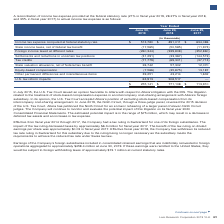According to Lam Research Corporation's financial document, What might the estimated potential impact being in the range of $75 million result in? a decrease in deferred tax assets and an increase in tax expense. The document states: "in the range of $75 million, which may result in a decrease in deferred tax assets and an increase in tax expense...." Also, What was the impact of tax ruling on taxes? decreased taxes by approximately $6.3 million for fiscal year 2017.. The document states: "foreign subsidiaries. The impact of the tax ruling decreased taxes by approximately $6.3 million for fiscal year 2017. The benefit of the tax ruling o..." Also, What is the amount of foreign withholding taxes at current statutory rates? According to the financial document, $73.1 million. The relevant text states: "ject to foreign withholding taxes of approximately $73.1 million at current statutory rates...." Also, can you calculate: What is the percentage change in the Income tax expense computed at federal statutory rate from 2018 to 2019? To answer this question, I need to perform calculations using the financial data. The calculation is: (513,780-891,011)/891,011, which equals -42.34 (percentage). This is based on the information: "tax expense computed at federal statutory rate $ 513,780 $ 891,011 $ 634,086 se computed at federal statutory rate $ 513,780 $ 891,011 $ 634,086..." The key data points involved are: 513,780, 891,011. Also, can you calculate: What is the percentage change in the Other permanent differences and miscellaneous items from 2018 to 2019? To answer this question, I need to perform calculations using the financial data. The calculation is: (39,251-43,214)/43,214, which equals -9.17 (percentage). This is based on the information: "her permanent differences and miscellaneous items 39,251 43,214 1,632 manent differences and miscellaneous items 39,251 43,214 1,632..." The key data points involved are: 39,251, 43,214. Additionally, In which year is the actual income tax expense the highest? According to the financial document, 2018. The relevant text states: "June 30, 2019 June 24, 2018 June 25, 2017..." 